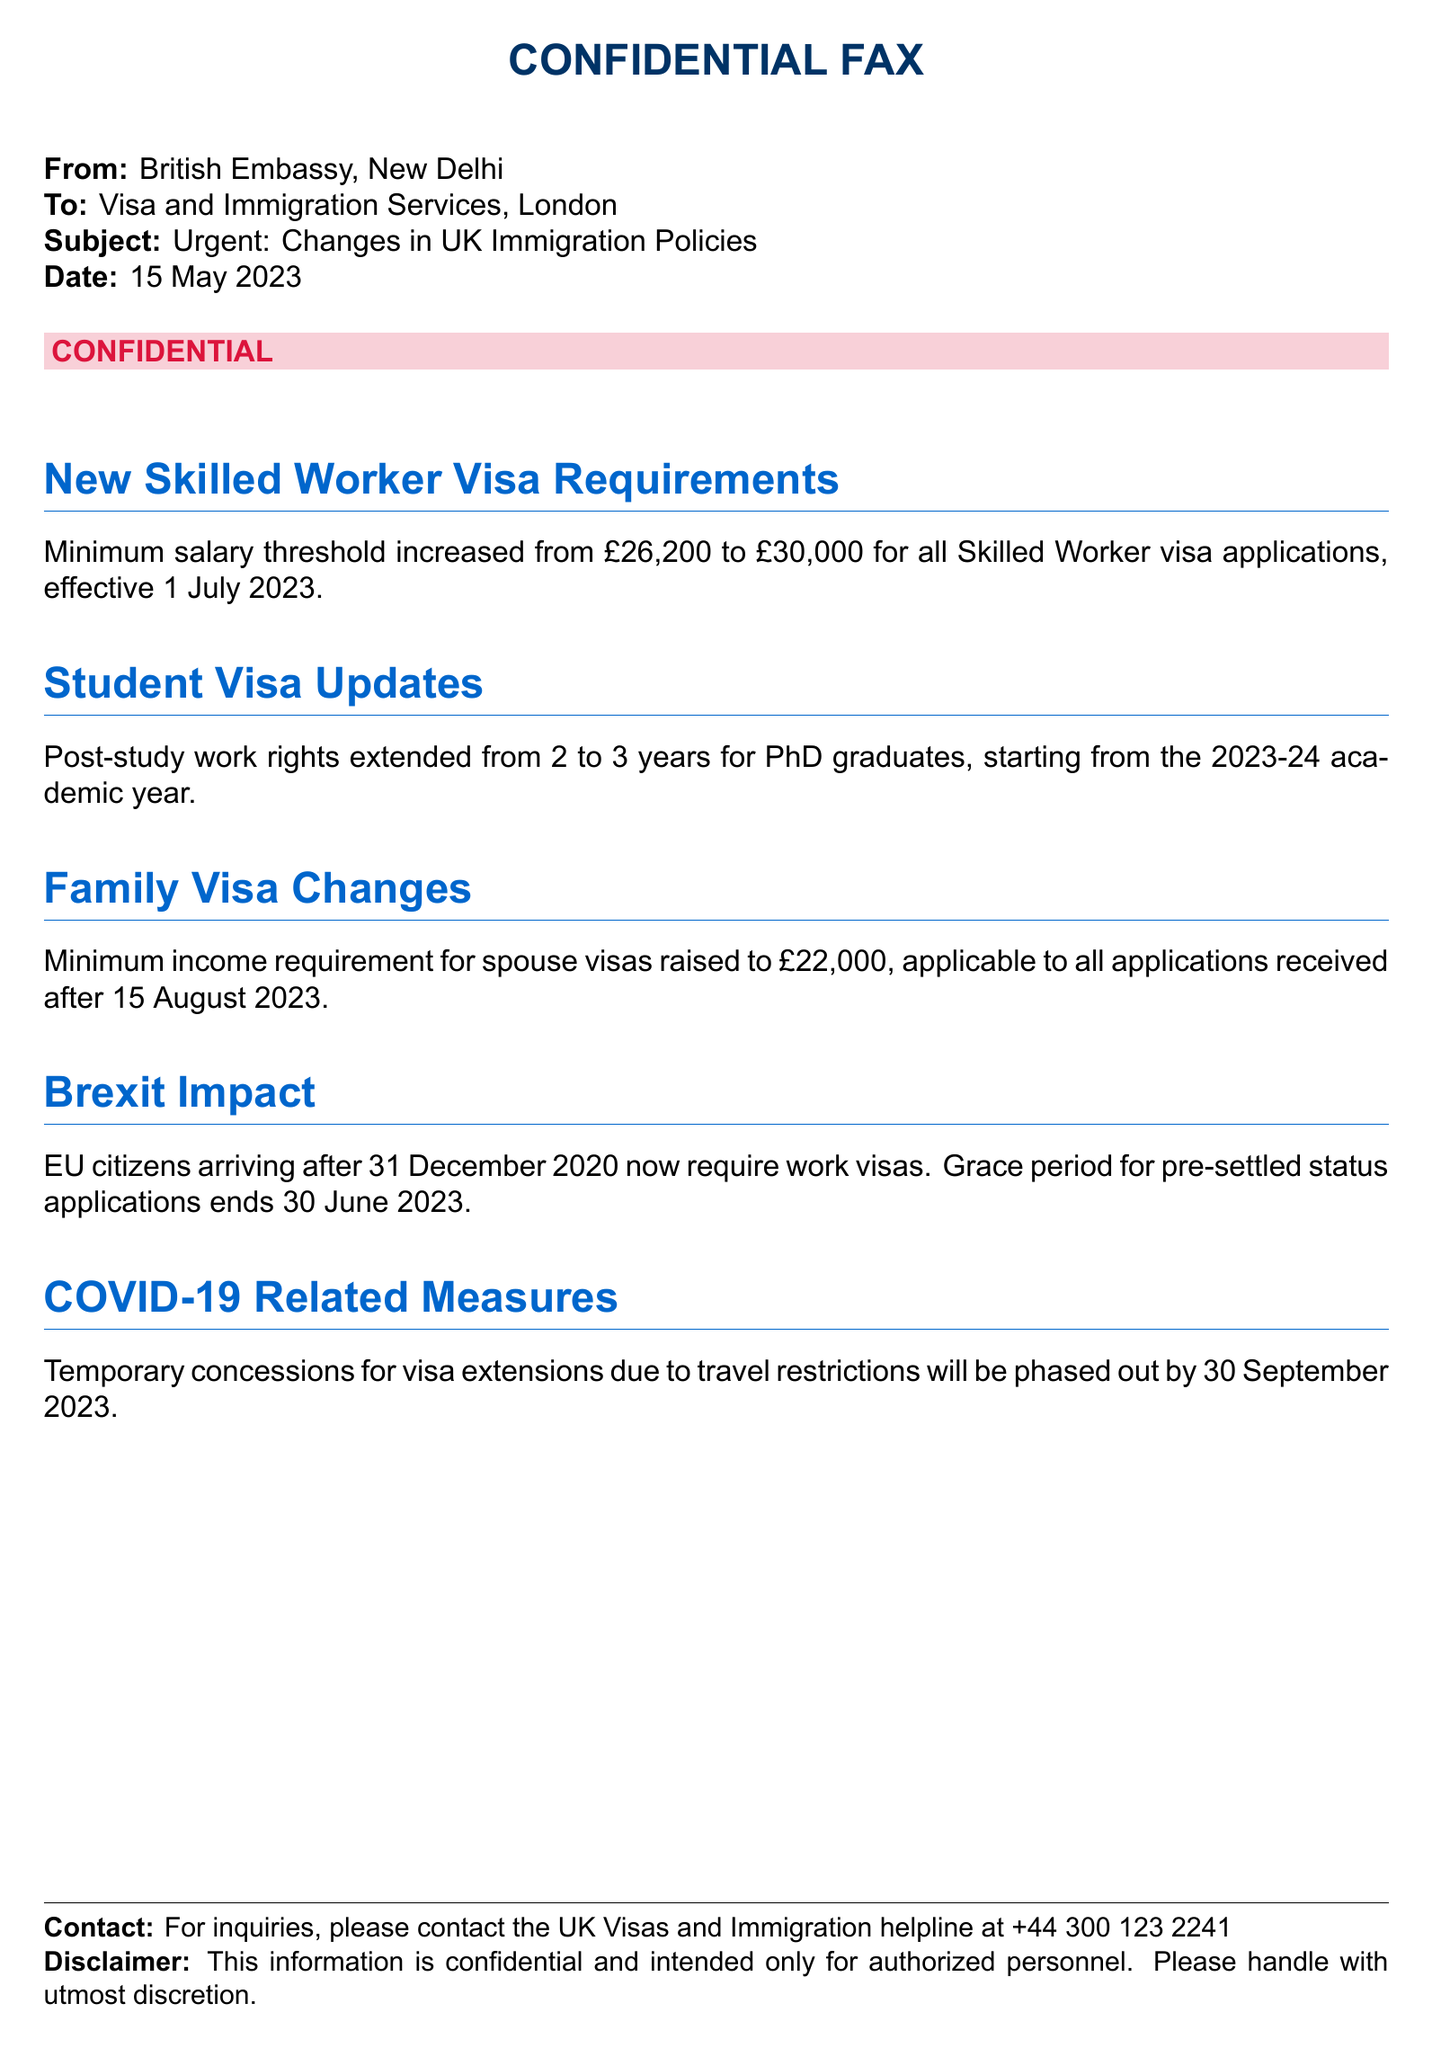What is the date of the fax? The date of the fax is explicitly stated in the document as the date when it was created, which is 15 May 2023.
Answer: 15 May 2023 What is the new minimum salary threshold for Skilled Worker visas? The document states that the minimum salary threshold for all Skilled Worker visa applications has increased, specifically mentioning the new amount of £30,000.
Answer: £30,000 When does the increased salary requirement for Skilled Worker visas take effect? It specifies an effective date for the new salary threshold, which is 1 July 2023.
Answer: 1 July 2023 What is the minimum income requirement for spouse visas? This requirement is stated to have been raised, and it specifies the new amount as £22,000 for all applications received after a certain date.
Answer: £22,000 What is the duration of post-study work rights extended to PhD graduates? The document mentions that post-study work rights have been extended from 2 years to a new duration specifically for PhD graduates.
Answer: 3 years What is the end date for the grace period for pre-settled status applications? The document provides a specific date when this grace period ends, which is crucial for EU citizens who arrived after a specific time.
Answer: 30 June 2023 What will happen to temporary visa extension concessions? The document notes the fate of these concessions due to travel restrictions, indicating they will no longer be available after a certain date.
Answer: Phased out by 30 September 2023 Who is the contact for inquiries mentioned in the fax? The document lists a specific helpline for inquiries related to visa and immigration matters.
Answer: UK Visas and Immigration helpline What is the significance of the term "CONFIDENTIAL" in the title? This term indicates the nature of the document, emphasizing that the information contained within should only be viewed by authorized personnel.
Answer: Confidential 